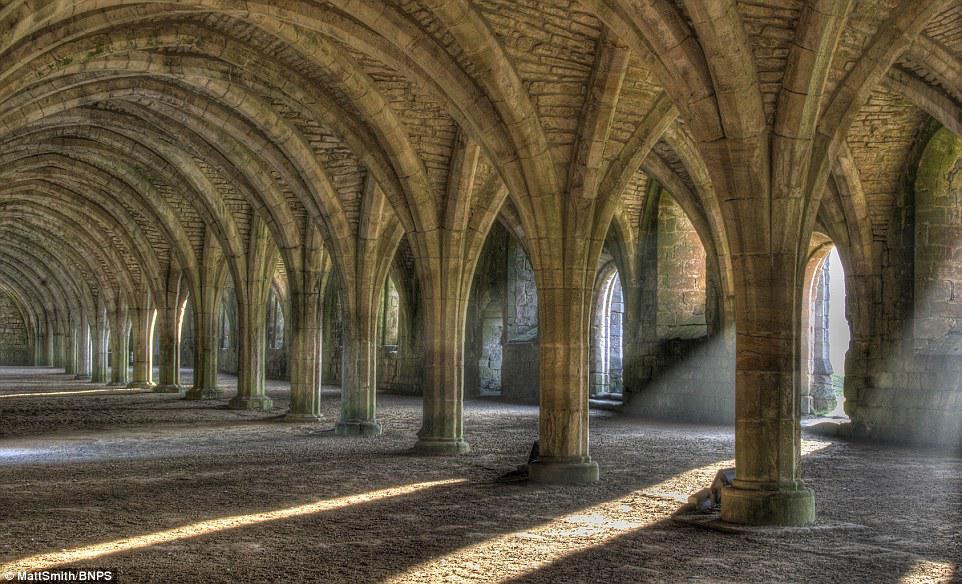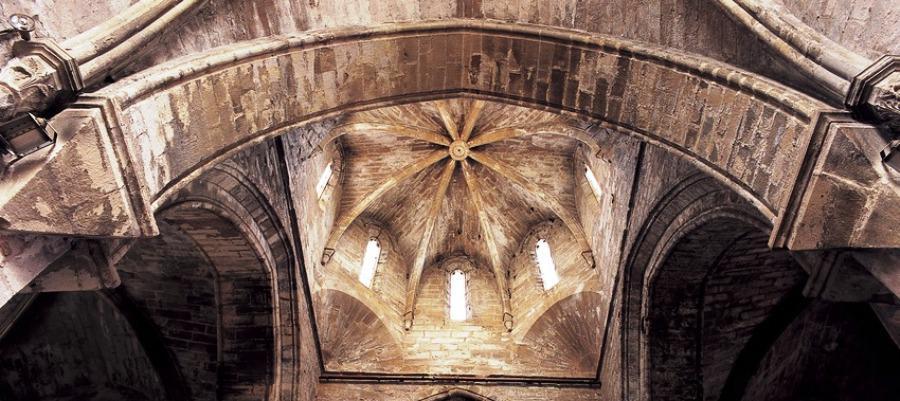The first image is the image on the left, the second image is the image on the right. Assess this claim about the two images: "more then six arches can be seen in the left photo". Correct or not? Answer yes or no. Yes. The first image is the image on the left, the second image is the image on the right. For the images displayed, is the sentence "In at least one image there are one or more paintings." factually correct? Answer yes or no. No. 